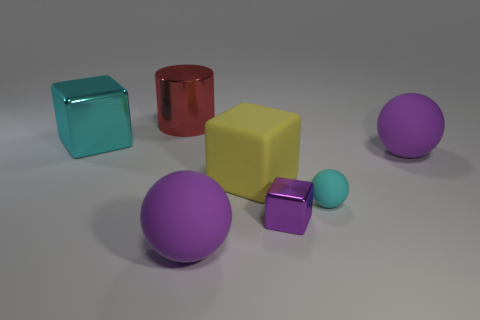Subtract all red spheres. Subtract all blue cylinders. How many spheres are left? 3 Add 2 tiny purple metal cubes. How many objects exist? 9 Subtract all spheres. How many objects are left? 4 Subtract all cyan things. Subtract all small cyan things. How many objects are left? 4 Add 4 purple blocks. How many purple blocks are left? 5 Add 7 metal cylinders. How many metal cylinders exist? 8 Subtract 0 brown cubes. How many objects are left? 7 